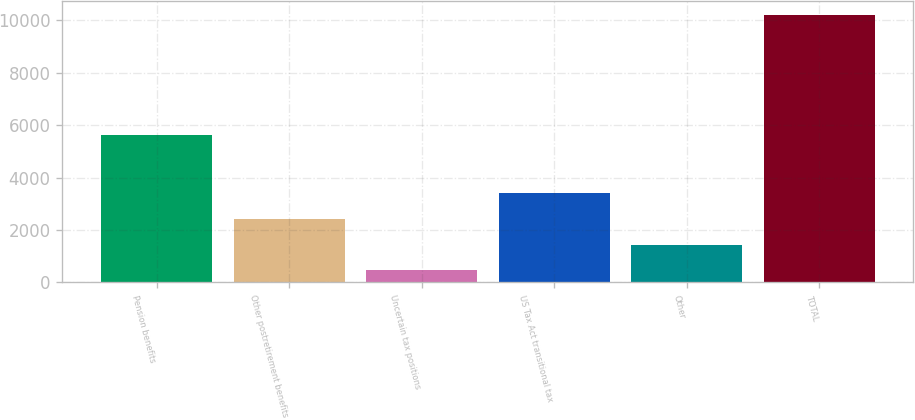Convert chart to OTSL. <chart><loc_0><loc_0><loc_500><loc_500><bar_chart><fcel>Pension benefits<fcel>Other postretirement benefits<fcel>Uncertain tax positions<fcel>US Tax Act transitional tax<fcel>Other<fcel>TOTAL<nl><fcel>5622<fcel>2419.8<fcel>472<fcel>3393.7<fcel>1445.9<fcel>10211<nl></chart> 